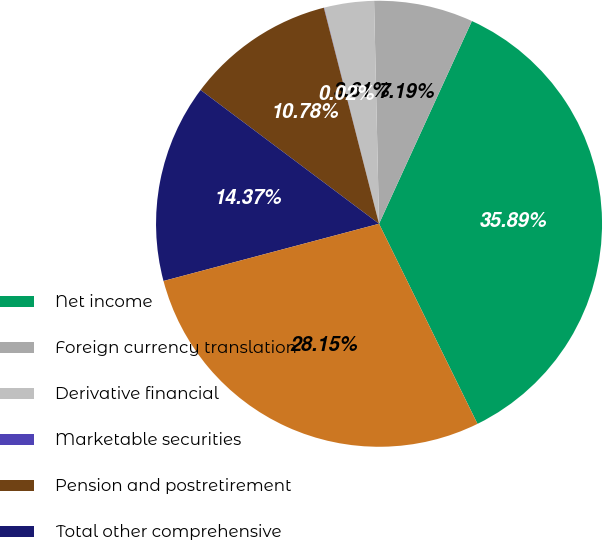<chart> <loc_0><loc_0><loc_500><loc_500><pie_chart><fcel>Net income<fcel>Foreign currency translation<fcel>Derivative financial<fcel>Marketable securities<fcel>Pension and postretirement<fcel>Total other comprehensive<fcel>Comprehensive income<nl><fcel>35.89%<fcel>7.19%<fcel>3.61%<fcel>0.02%<fcel>10.78%<fcel>14.37%<fcel>28.15%<nl></chart> 